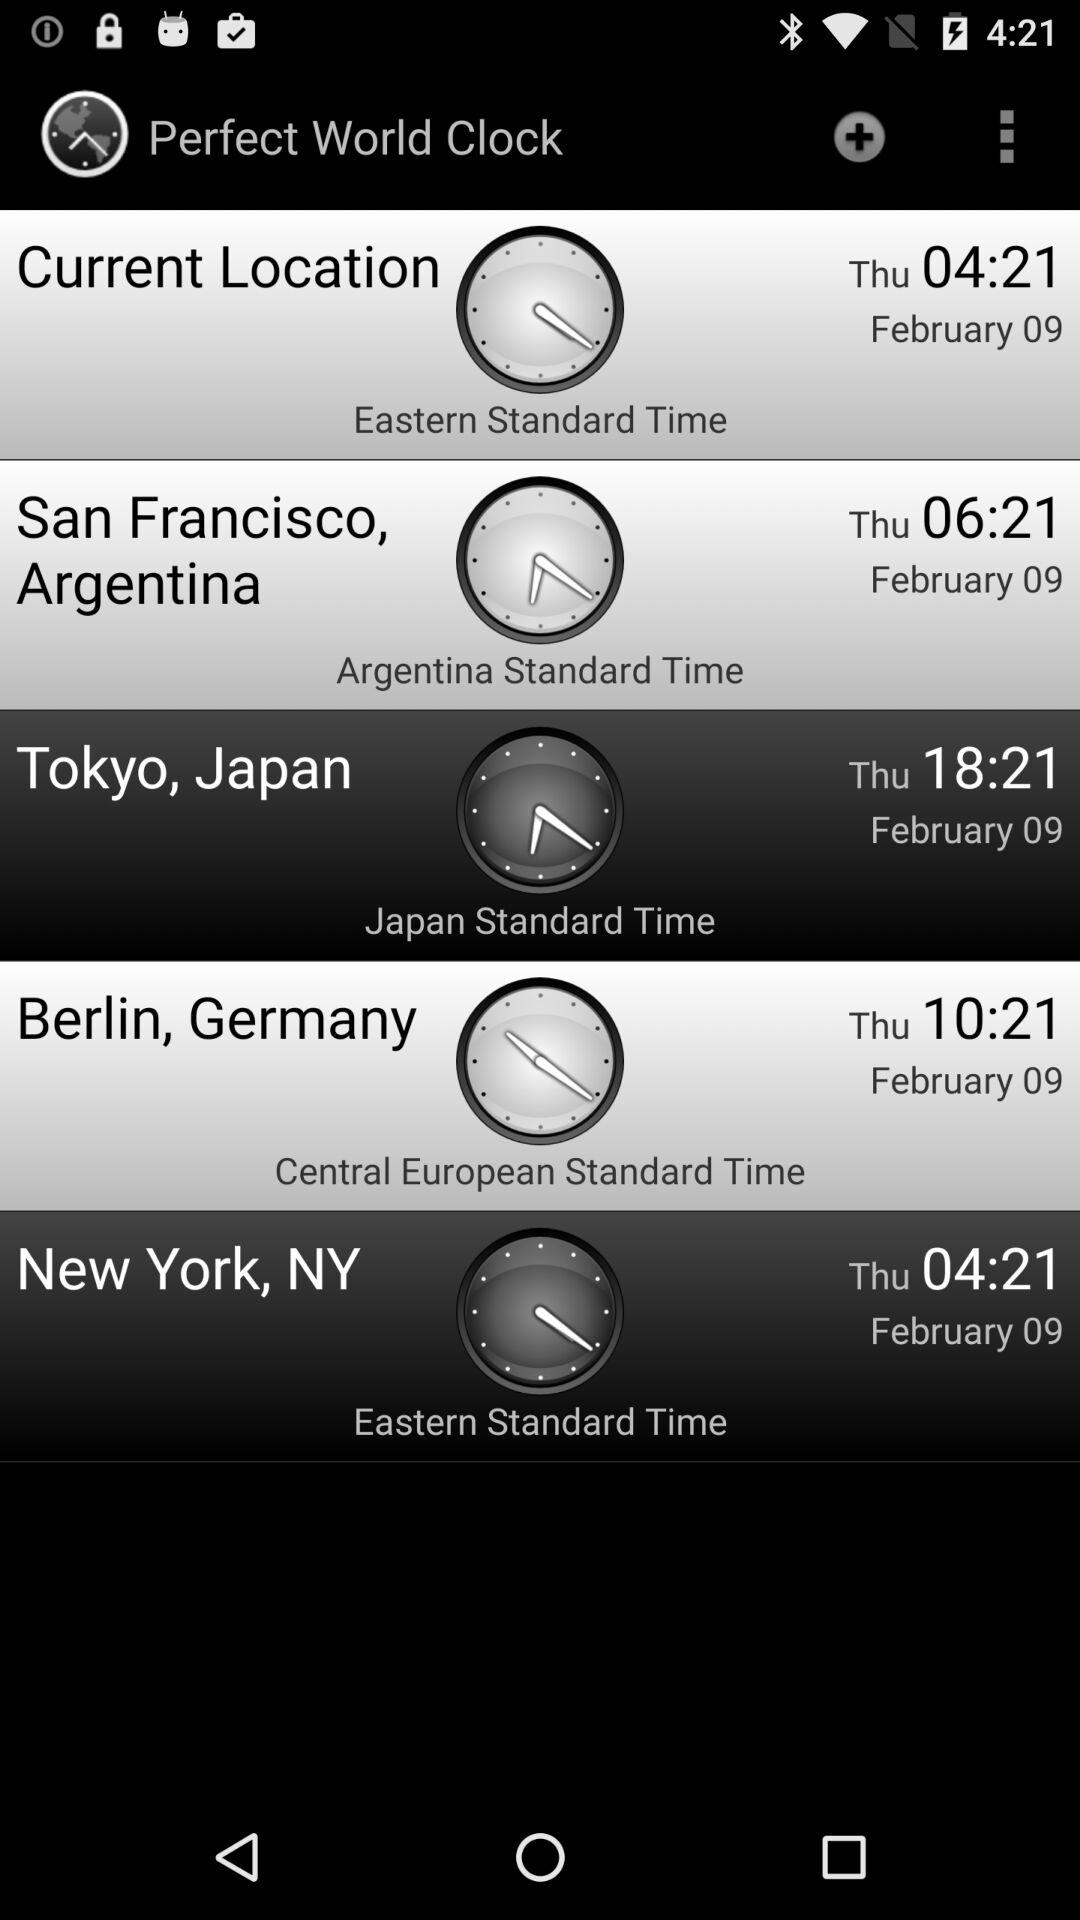Which city has Eastern Standard Time? The city that has Eastern Standard Time is New York. 